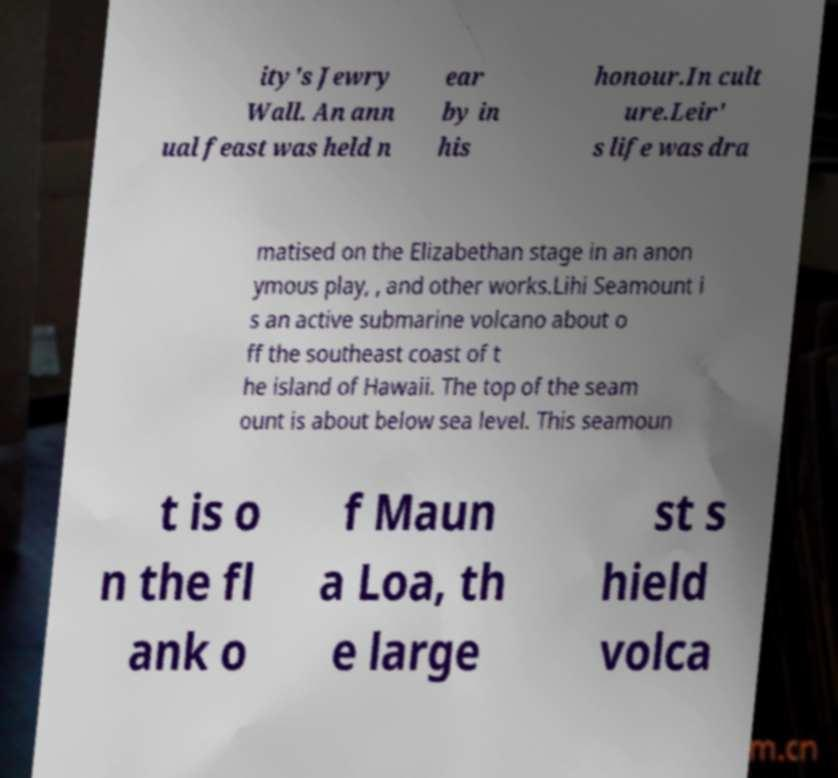I need the written content from this picture converted into text. Can you do that? ity's Jewry Wall. An ann ual feast was held n ear by in his honour.In cult ure.Leir' s life was dra matised on the Elizabethan stage in an anon ymous play, , and other works.Lihi Seamount i s an active submarine volcano about o ff the southeast coast of t he island of Hawaii. The top of the seam ount is about below sea level. This seamoun t is o n the fl ank o f Maun a Loa, th e large st s hield volca 